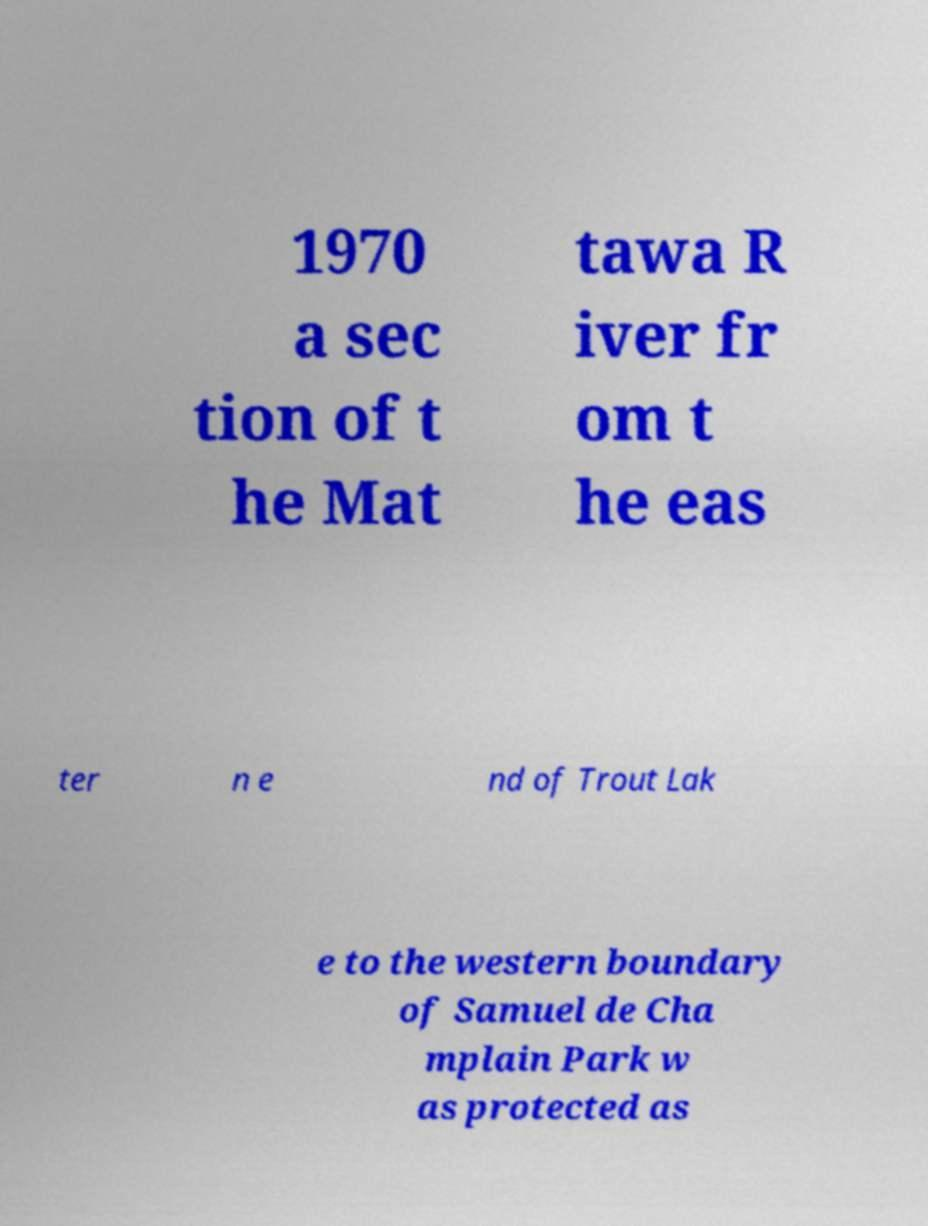Could you extract and type out the text from this image? 1970 a sec tion of t he Mat tawa R iver fr om t he eas ter n e nd of Trout Lak e to the western boundary of Samuel de Cha mplain Park w as protected as 